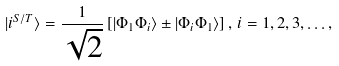<formula> <loc_0><loc_0><loc_500><loc_500>| i ^ { S / T } \rangle = \frac { 1 } { \sqrt { 2 } } \left [ | \Phi _ { 1 } \Phi _ { i } \rangle \pm | \Phi _ { i } \Phi _ { 1 } \rangle \right ] , \, i = 1 , 2 , 3 , \dots ,</formula> 